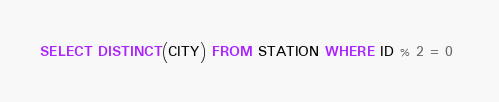Convert code to text. <code><loc_0><loc_0><loc_500><loc_500><_SQL_>SELECT DISTINCT(CITY) FROM STATION WHERE ID % 2 = 0 </code> 